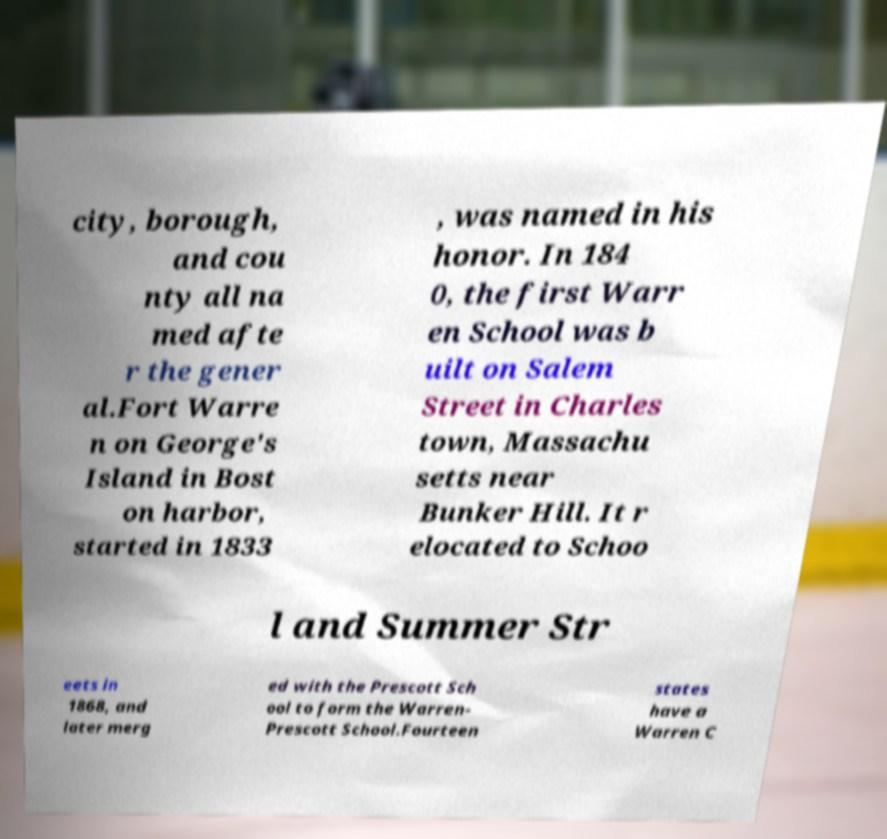Could you extract and type out the text from this image? city, borough, and cou nty all na med afte r the gener al.Fort Warre n on George's Island in Bost on harbor, started in 1833 , was named in his honor. In 184 0, the first Warr en School was b uilt on Salem Street in Charles town, Massachu setts near Bunker Hill. It r elocated to Schoo l and Summer Str eets in 1868, and later merg ed with the Prescott Sch ool to form the Warren- Prescott School.Fourteen states have a Warren C 